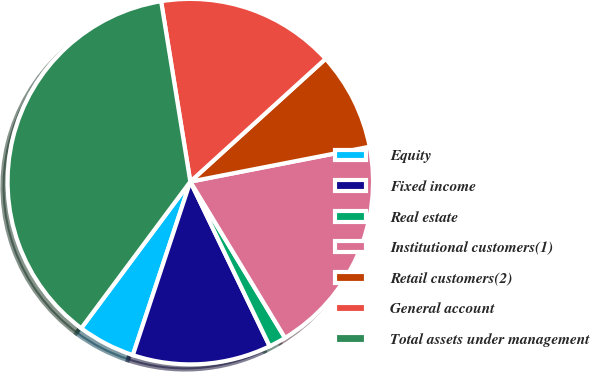<chart> <loc_0><loc_0><loc_500><loc_500><pie_chart><fcel>Equity<fcel>Fixed income<fcel>Real estate<fcel>Institutional customers(1)<fcel>Retail customers(2)<fcel>General account<fcel>Total assets under management<nl><fcel>5.09%<fcel>12.24%<fcel>1.52%<fcel>19.39%<fcel>8.67%<fcel>15.82%<fcel>37.26%<nl></chart> 